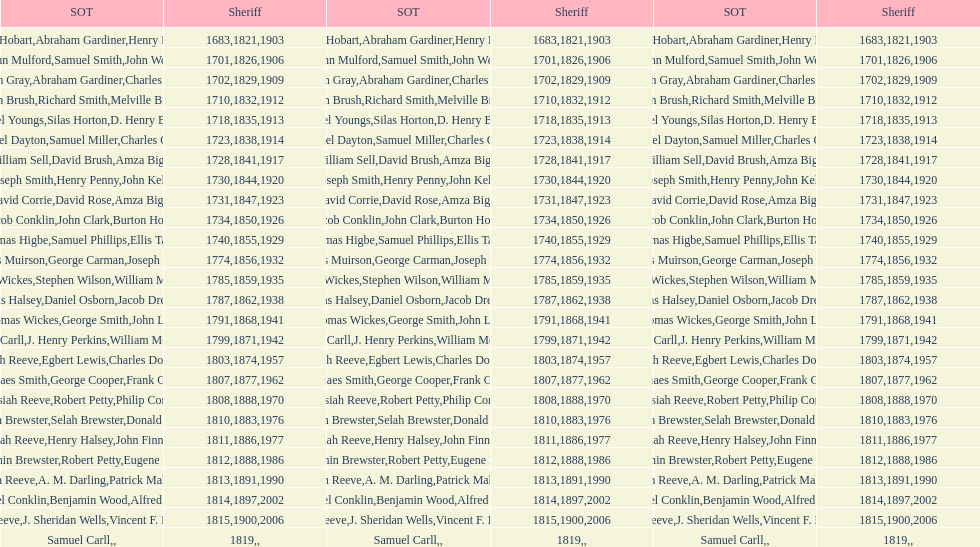When did the first sheriff's term start? 1683. 